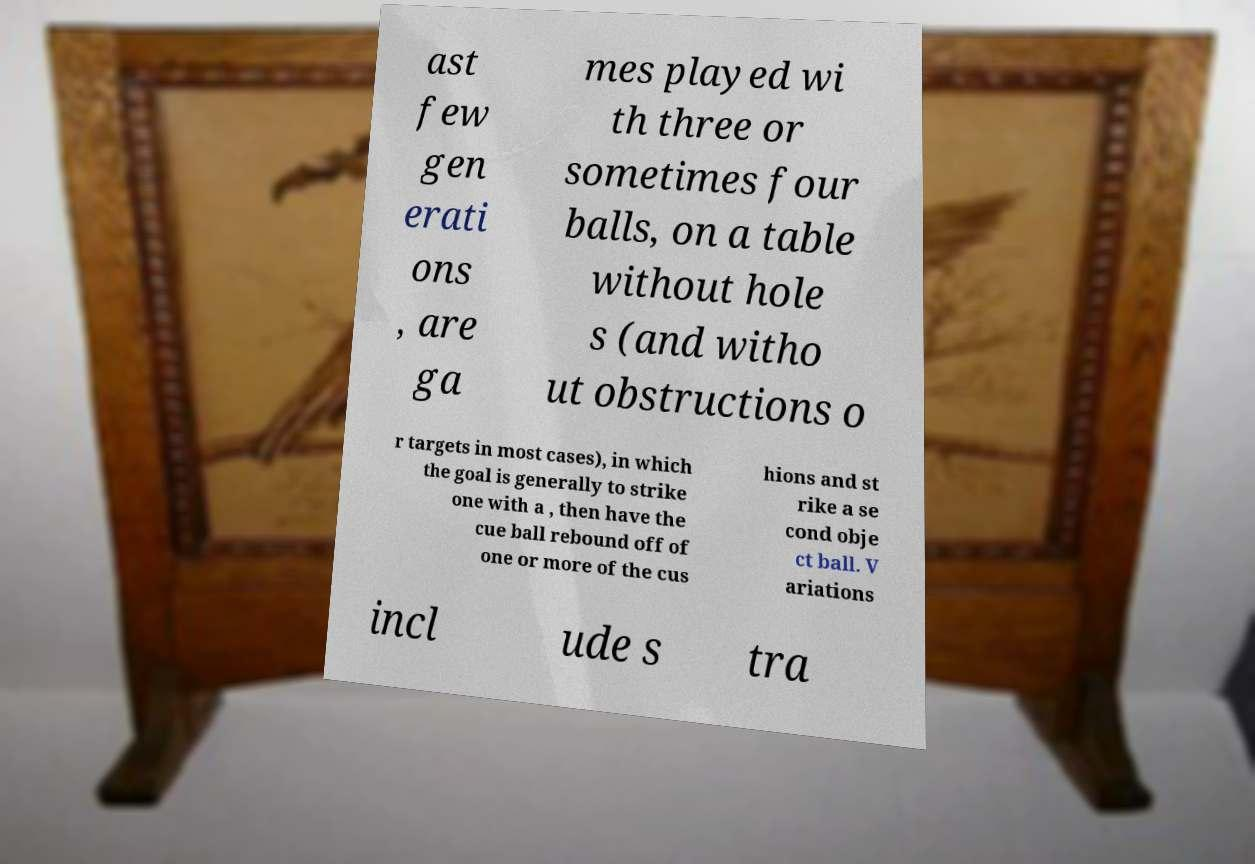There's text embedded in this image that I need extracted. Can you transcribe it verbatim? ast few gen erati ons , are ga mes played wi th three or sometimes four balls, on a table without hole s (and witho ut obstructions o r targets in most cases), in which the goal is generally to strike one with a , then have the cue ball rebound off of one or more of the cus hions and st rike a se cond obje ct ball. V ariations incl ude s tra 